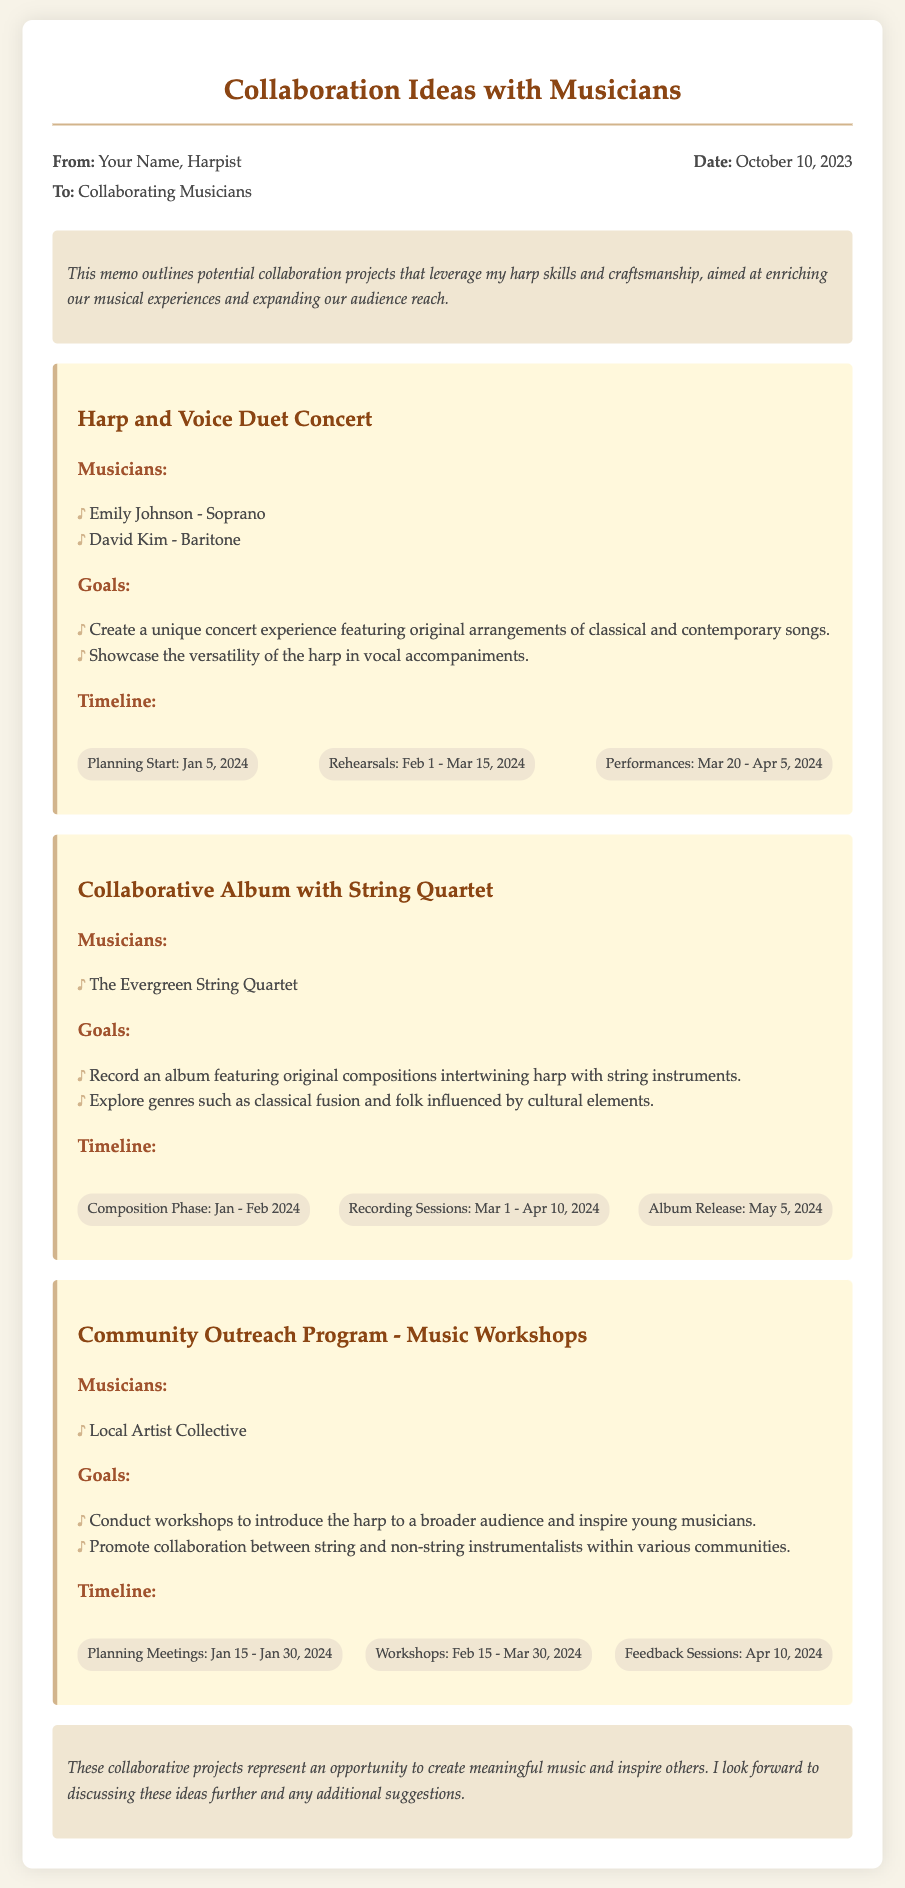What is the date of the memo? The date of the memo is listed in the memo header section, which is October 10, 2023.
Answer: October 10, 2023 Who are the musicians involved in the Harp and Voice Duet Concert? The musicians involved are cited under the project section specifically for that concert, which includes Emily Johnson and David Kim.
Answer: Emily Johnson - Soprano, David Kim - Baritone What is the goal of the Community Outreach Program? The goal is mentioned in the project section and requires understanding the intended outcomes of the workshops.
Answer: Conduct workshops to introduce the harp to a broader audience and inspire young musicians What are the timelines for the Collaborative Album with String Quartet? The timelines are broken down in the project section under the Collaborative Album project, highlighting different phases.
Answer: Composition Phase: Jan - Feb 2024, Recording Sessions: Mar 1 - Apr 10, 2024, Album Release: May 5, 2024 When do rehearsals start for the Harp and Voice Duet Concert? The rehearsals timeframe is specifically indicated in the timeline of the Harp and Voice Duet Concert project.
Answer: Feb 1 - Mar 15, 2024 Who is the local artist collective collaborating on the Community Outreach Program? The local artist collective is mentioned in the project section of the Community Outreach Program.
Answer: Local Artist Collective What type of music is being recorded for the Collaborative Album? The type of music is indicated in the goals of the project and focuses on the combination of genres.
Answer: Original compositions intertwining harp with string instruments How long is the feedback session scheduled for the Community Outreach Program? The duration of the feedback session is noted in the timeline, which specifies the date it will occur.
Answer: Apr 10, 2024 